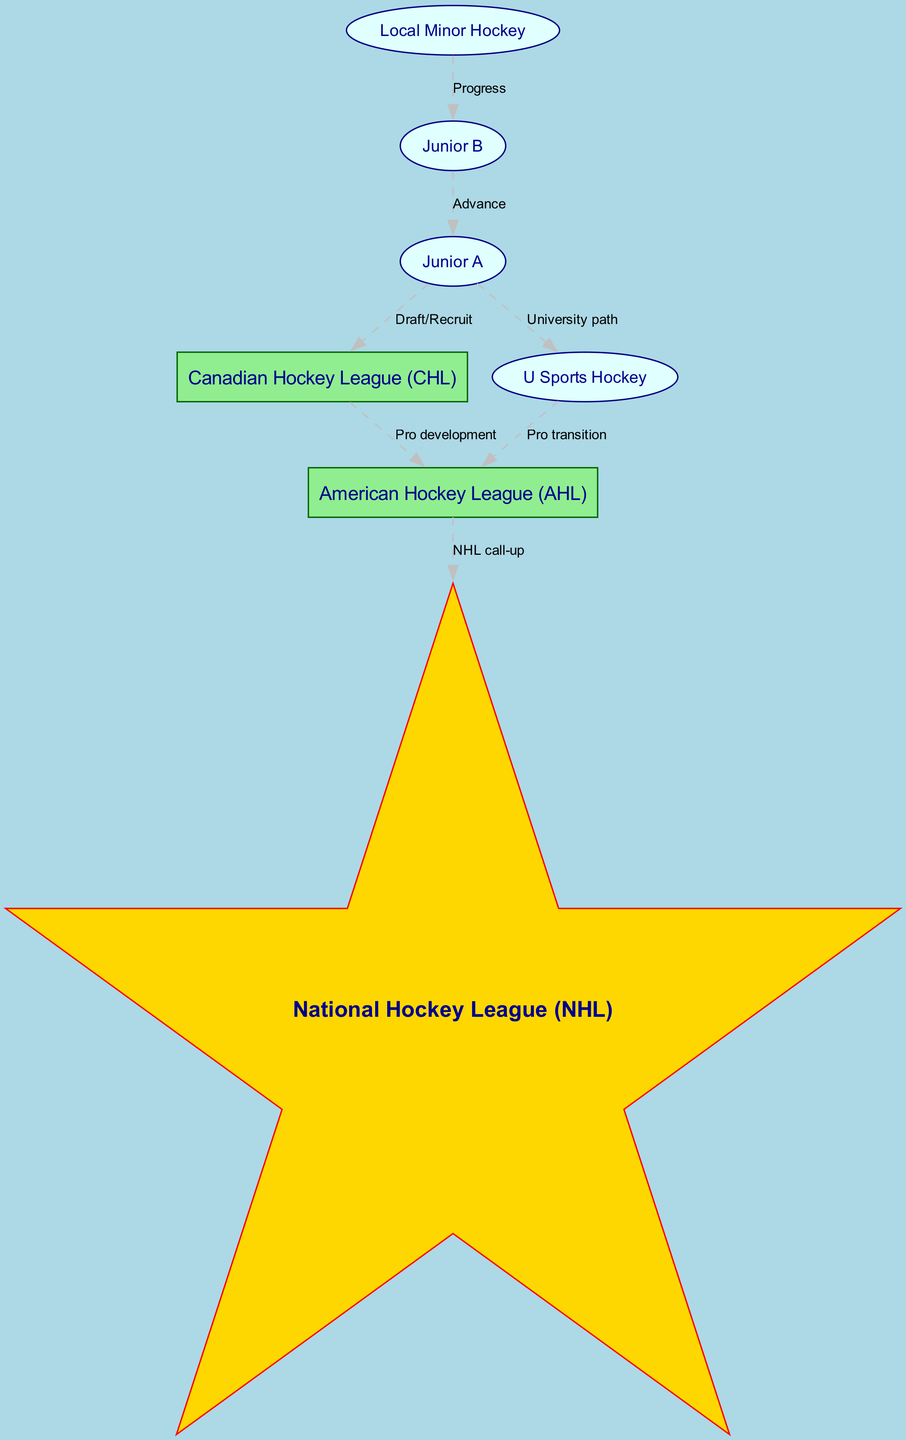What is the starting point in the hockey league hierarchy? The starting point node in the diagram is "Local Minor Hockey," which is the entry level for players before moving into higher tiers.
Answer: Local Minor Hockey How many nodes are present in the diagram? By counting the unique nodes listed, we find there are seven nodes representing different levels in the hockey hierarchy.
Answer: 7 What league does "Junior A" transition into? From the diagram, "Junior A" has two transition paths, one leading to "Canadian Hockey League (CHL)" and the other to "U Sports Hockey."
Answer: Canadian Hockey League (CHL), U Sports Hockey Which league is directly above the "American Hockey League (AHL)"? According to the diagram, the "American Hockey League (AHL)" is followed directly by the "National Hockey League (NHL)" as its next level.
Answer: National Hockey League (NHL) What is the relationship between "Canadian Hockey League (CHL)" and "American Hockey League (AHL)"? The diagram indicates that the relationship is one of "Pro development," showing the progression from CHL to AHL for professional growth.
Answer: Pro development After "Junior A," what path can lead to university hockey? From "Junior A," players can take the path labeled "University path," which indicates the transition towards "U Sports Hockey."
Answer: U Sports Hockey How many edges are there in the diagram? To determine the number of connections (edges) in the graph, we count all the directed relationships drawn between nodes, totaling six distinct edges.
Answer: 6 What label connects "U Sports Hockey" to "American Hockey League (AHL)"? The connection from "U Sports Hockey" to "American Hockey League (AHL)" is marked with the label "Pro transition," indicating the movement into professional ranks.
Answer: Pro transition Which node serves a dual pathway from "Junior A"? "Junior A" serves as a dual pathway leading to both "Canadian Hockey League (CHL)" and "U Sports Hockey," indicating two distinct career paths for players.
Answer: Canadian Hockey League (CHL), U Sports Hockey 